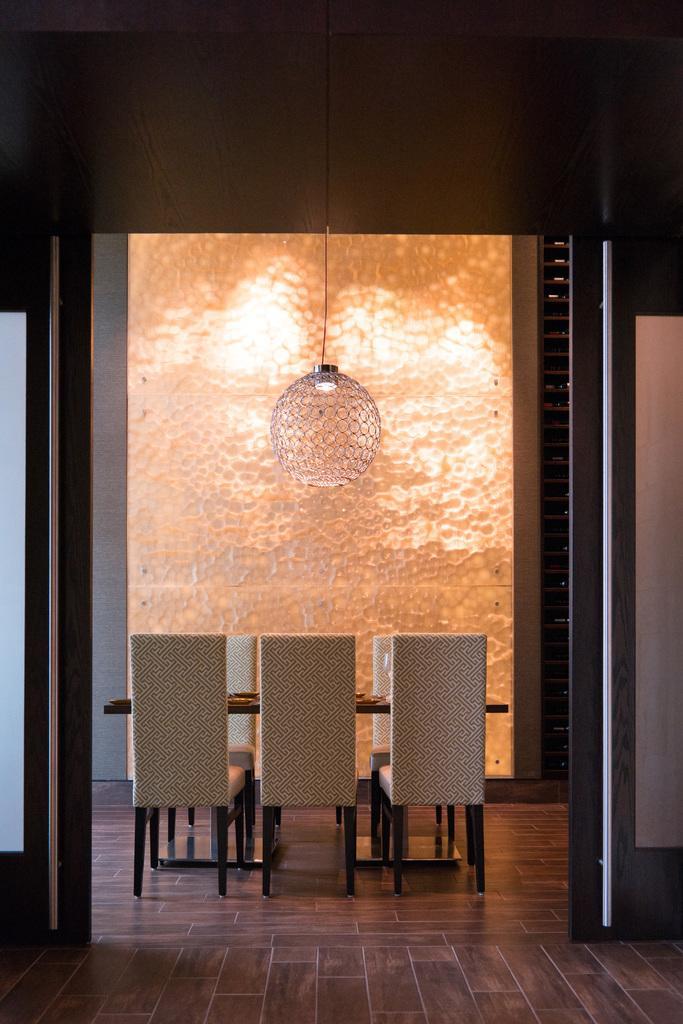How would you summarize this image in a sentence or two? In this image I can see few chairs, table, light and brown color floor. Background is in orange and white color. 